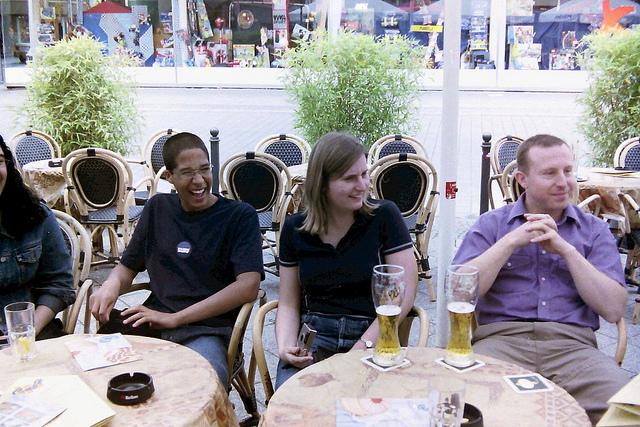How many women?
Quick response, please. 2. How many people are seated at the table?
Be succinct. 4. How many people is being fully shown in this picture?
Write a very short answer. 3. 